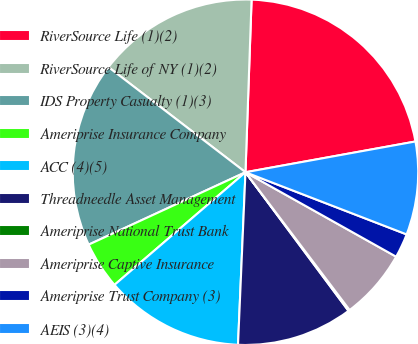Convert chart to OTSL. <chart><loc_0><loc_0><loc_500><loc_500><pie_chart><fcel>RiverSource Life (1)(2)<fcel>RiverSource Life of NY (1)(2)<fcel>IDS Property Casualty (1)(3)<fcel>Ameriprise Insurance Company<fcel>ACC (4)(5)<fcel>Threadneedle Asset Management<fcel>Ameriprise National Trust Bank<fcel>Ameriprise Captive Insurance<fcel>Ameriprise Trust Company (3)<fcel>AEIS (3)(4)<nl><fcel>21.59%<fcel>15.15%<fcel>17.3%<fcel>4.42%<fcel>13.01%<fcel>10.86%<fcel>0.13%<fcel>6.57%<fcel>2.27%<fcel>8.71%<nl></chart> 